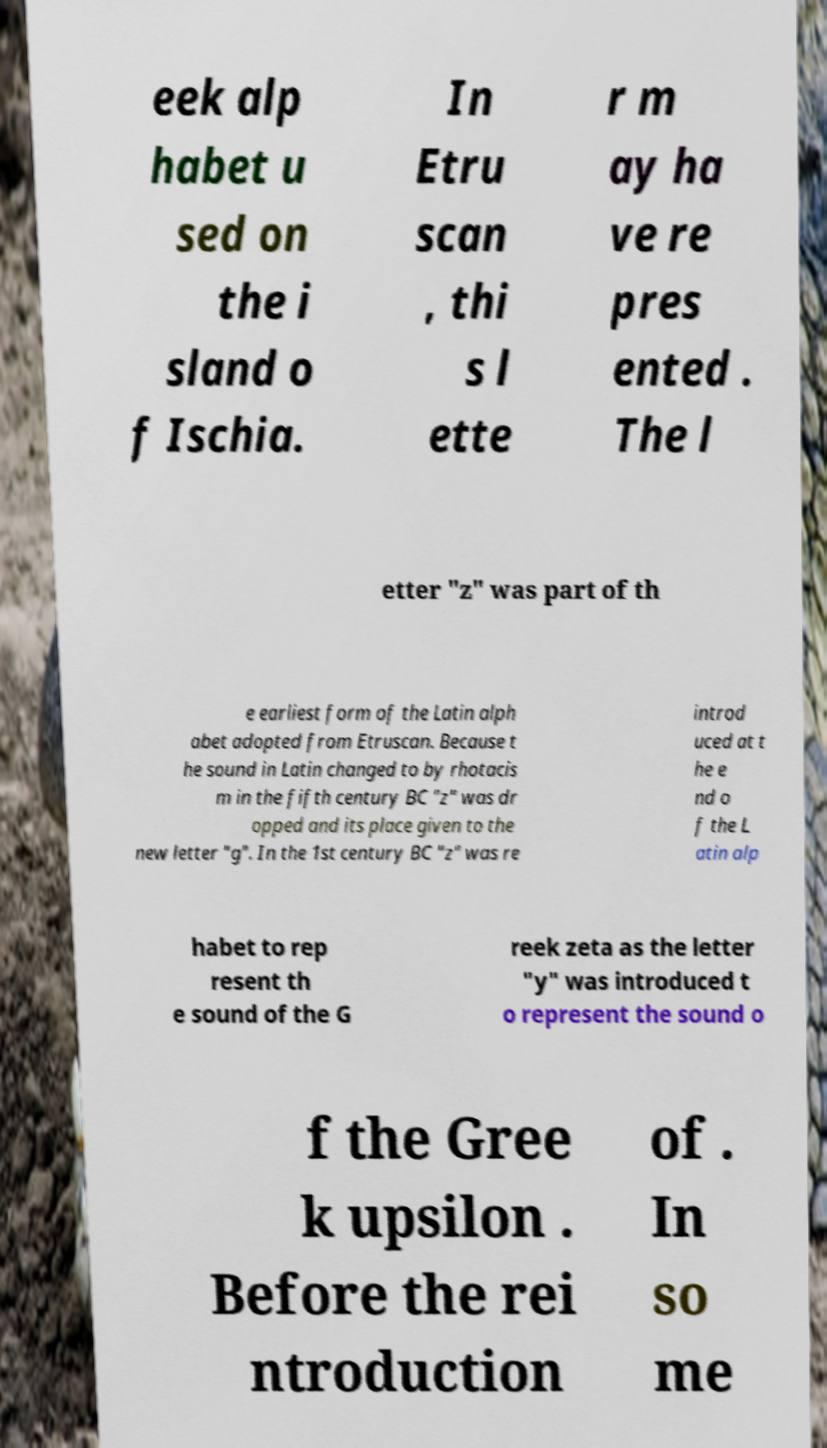Could you assist in decoding the text presented in this image and type it out clearly? eek alp habet u sed on the i sland o f Ischia. In Etru scan , thi s l ette r m ay ha ve re pres ented . The l etter "z" was part of th e earliest form of the Latin alph abet adopted from Etruscan. Because t he sound in Latin changed to by rhotacis m in the fifth century BC "z" was dr opped and its place given to the new letter "g". In the 1st century BC "z" was re introd uced at t he e nd o f the L atin alp habet to rep resent th e sound of the G reek zeta as the letter "y" was introduced t o represent the sound o f the Gree k upsilon . Before the rei ntroduction of . In so me 